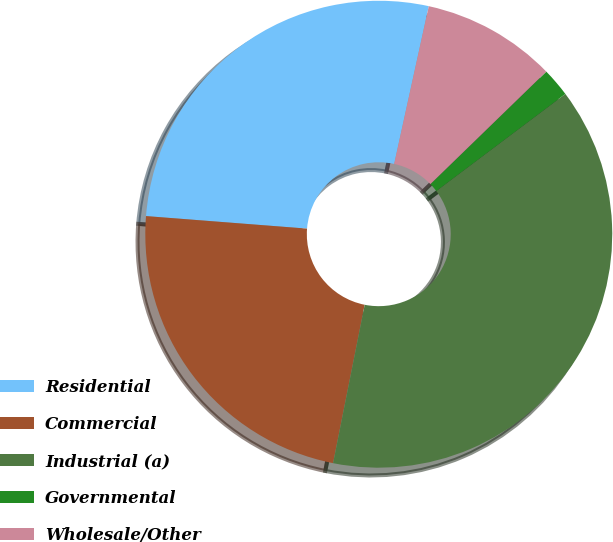Convert chart. <chart><loc_0><loc_0><loc_500><loc_500><pie_chart><fcel>Residential<fcel>Commercial<fcel>Industrial (a)<fcel>Governmental<fcel>Wholesale/Other<nl><fcel>27.2%<fcel>23.1%<fcel>38.4%<fcel>2.0%<fcel>9.3%<nl></chart> 